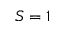Convert formula to latex. <formula><loc_0><loc_0><loc_500><loc_500>S = 1</formula> 